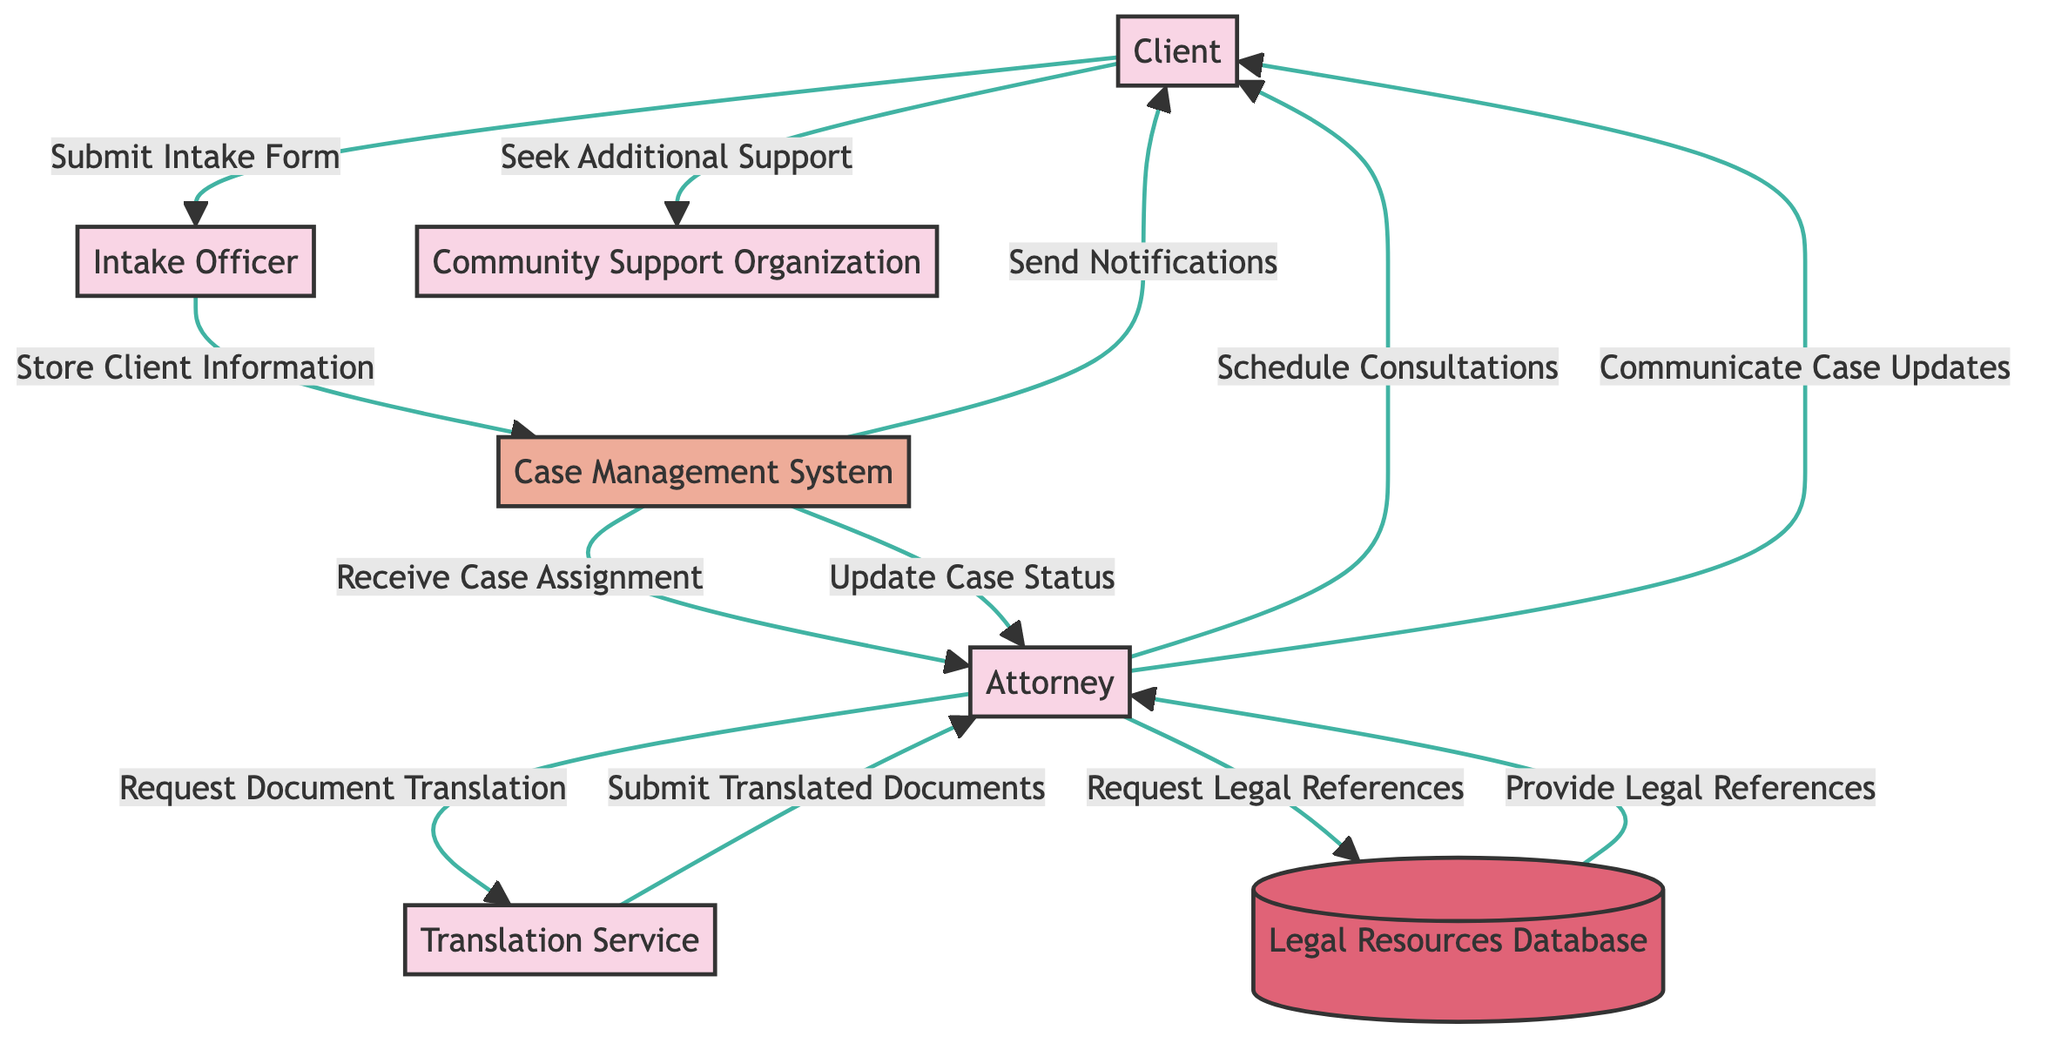What is the role of the Client in this diagram? The Client's role involves submitting the intake form, providing documents, receiving notifications, and participating in consultations as part of the legal aid process. These interactions can be traced directly from the diagram where the Client connects with multiple entities.
Answer: Hispanic immigrant seeking legal aid How many entities are involved in the process outlined in the diagram? By counting each of the distinct entities shown in the diagram: Client, Intake Officer, Attorney, Translation Service, Case Management System, Legal Resources Database, and Community Support Organization, we can find the total number. Thus, there are seven entities involved.
Answer: 7 What flows from the Intake Officer to the Case Management System? The Intake Officer sends the Client's information to the Case Management System to store it after reviewing the client's intake form. This information flow is present within the diagram's connections.
Answer: Store Client Information Which service translates communications between the Client and the Attorney? The Translation Service is responsible for translating communications between the Client and the Attorney, as indicated in the arrows and content listed in the diagram.
Answer: Translation Service What is the primary function of the Case Management System? The main function of the Case Management System is to manage immigrant cases, which includes storing client information, tracking case progress, generating reports, and sending notifications, as described clearly in the diagram.
Answer: Digital platform for managing immigrant cases Which two entities exchange requests and references? The Attorney and Legal Resources Database interact through requests for legal references. The Attorney sends requests to the Legal Resources Database, which provides the needed legal references back to the Attorney. This back-and-forth flow establishes their connection.
Answer: Attorney and Legal Resources Database What happens after the Attorney requests a document translation? After the Attorney requests document translation, the Translation Service processes the request and submits the translated documents back to the Attorney. This process is illustrated through the respective arrows and content flows in the diagram.
Answer: Submit Translated Documents What action does the Client take with the Community Support Organization? The Client seeks additional support from the Community Support Organization, indicating the role of community organizations in providing assistance outside of legal services. This interaction is explicitly shown in the flow between the entities.
Answer: Seek Additional Support 